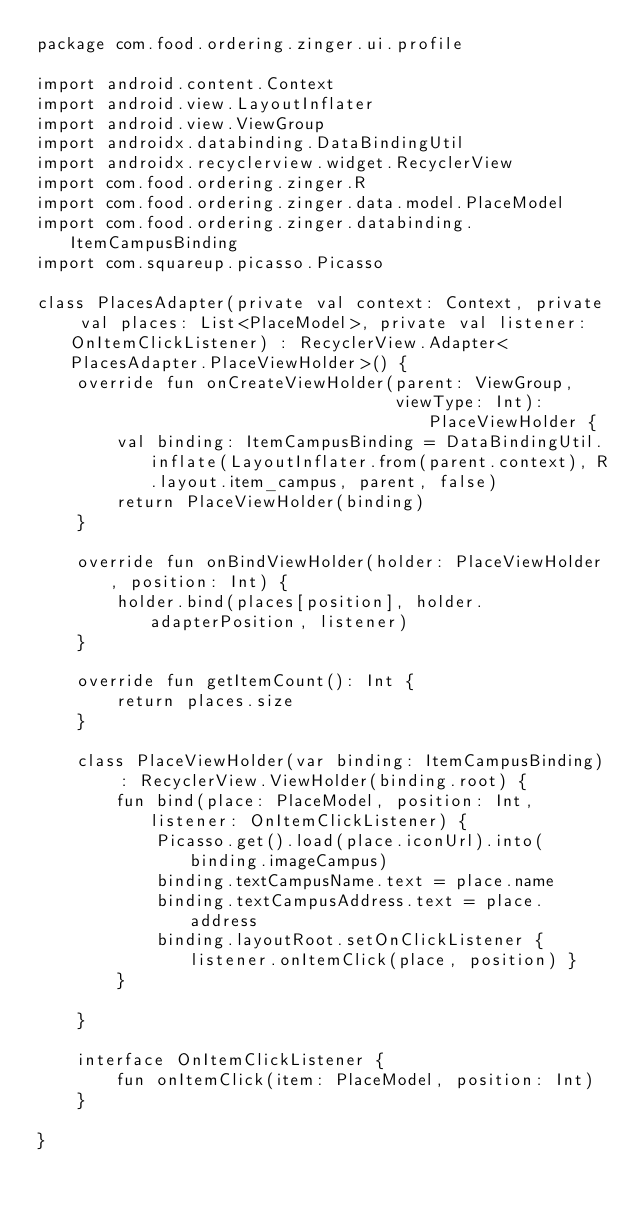Convert code to text. <code><loc_0><loc_0><loc_500><loc_500><_Kotlin_>package com.food.ordering.zinger.ui.profile

import android.content.Context
import android.view.LayoutInflater
import android.view.ViewGroup
import androidx.databinding.DataBindingUtil
import androidx.recyclerview.widget.RecyclerView
import com.food.ordering.zinger.R
import com.food.ordering.zinger.data.model.PlaceModel
import com.food.ordering.zinger.databinding.ItemCampusBinding
import com.squareup.picasso.Picasso

class PlacesAdapter(private val context: Context, private val places: List<PlaceModel>, private val listener: OnItemClickListener) : RecyclerView.Adapter<PlacesAdapter.PlaceViewHolder>() {
    override fun onCreateViewHolder(parent: ViewGroup,
                                    viewType: Int): PlaceViewHolder {
        val binding: ItemCampusBinding = DataBindingUtil.inflate(LayoutInflater.from(parent.context), R.layout.item_campus, parent, false)
        return PlaceViewHolder(binding)
    }

    override fun onBindViewHolder(holder: PlaceViewHolder, position: Int) {
        holder.bind(places[position], holder.adapterPosition, listener)
    }

    override fun getItemCount(): Int {
        return places.size
    }

    class PlaceViewHolder(var binding: ItemCampusBinding) : RecyclerView.ViewHolder(binding.root) {
        fun bind(place: PlaceModel, position: Int, listener: OnItemClickListener) {
            Picasso.get().load(place.iconUrl).into(binding.imageCampus)
            binding.textCampusName.text = place.name
            binding.textCampusAddress.text = place.address
            binding.layoutRoot.setOnClickListener { listener.onItemClick(place, position) }
        }

    }

    interface OnItemClickListener {
        fun onItemClick(item: PlaceModel, position: Int)
    }

}</code> 